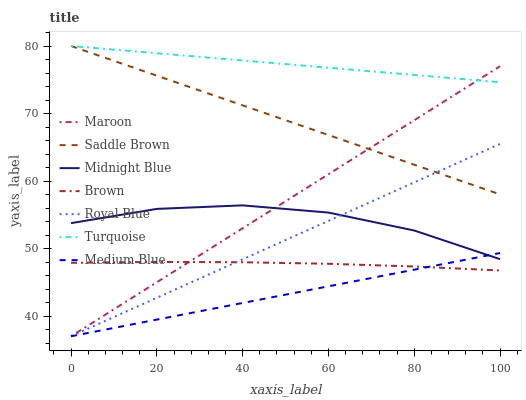Does Midnight Blue have the minimum area under the curve?
Answer yes or no. No. Does Midnight Blue have the maximum area under the curve?
Answer yes or no. No. Is Turquoise the smoothest?
Answer yes or no. No. Is Turquoise the roughest?
Answer yes or no. No. Does Midnight Blue have the lowest value?
Answer yes or no. No. Does Midnight Blue have the highest value?
Answer yes or no. No. Is Midnight Blue less than Turquoise?
Answer yes or no. Yes. Is Saddle Brown greater than Brown?
Answer yes or no. Yes. Does Midnight Blue intersect Turquoise?
Answer yes or no. No. 